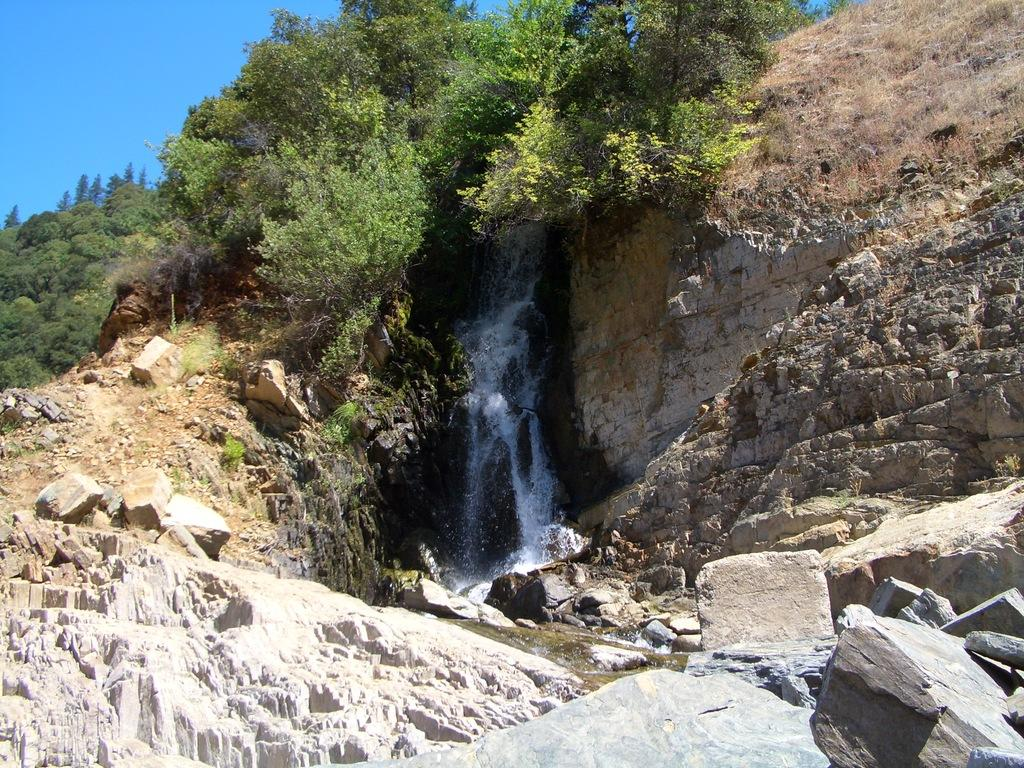What natural feature is the main subject of the image? There is a waterfall in the image. What other elements can be seen in the image? There are rocks, trees, and stones in the image. What is visible in the background of the image? The sky is visible in the image. Can you describe the eyes of the creature in the image? There is no creature present in the image, so there are no eyes to describe. 